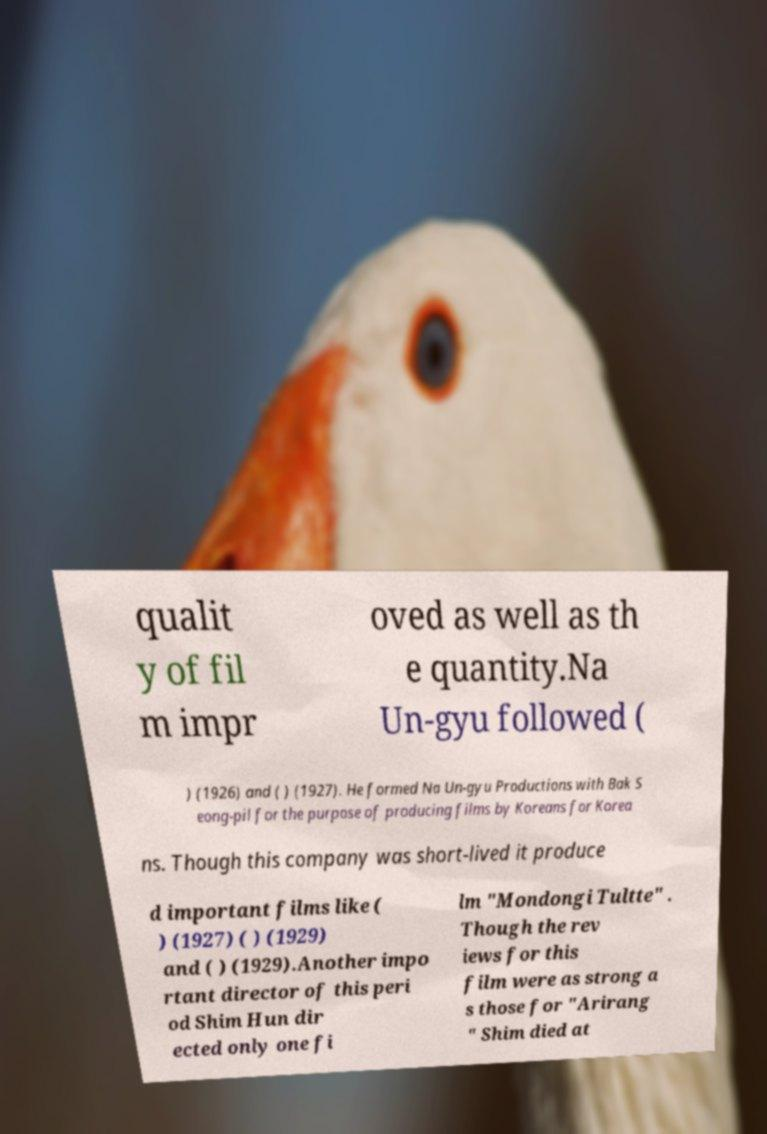There's text embedded in this image that I need extracted. Can you transcribe it verbatim? qualit y of fil m impr oved as well as th e quantity.Na Un-gyu followed ( ) (1926) and ( ) (1927). He formed Na Un-gyu Productions with Bak S eong-pil for the purpose of producing films by Koreans for Korea ns. Though this company was short-lived it produce d important films like ( ) (1927) ( ) (1929) and ( ) (1929).Another impo rtant director of this peri od Shim Hun dir ected only one fi lm "Mondongi Tultte" . Though the rev iews for this film were as strong a s those for "Arirang " Shim died at 